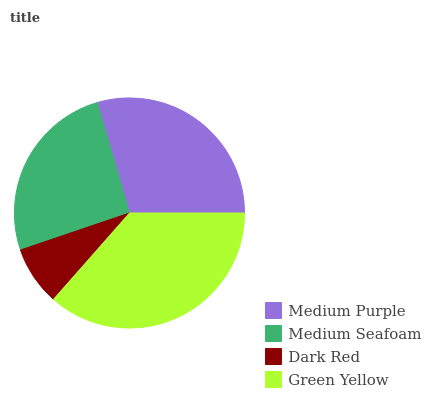Is Dark Red the minimum?
Answer yes or no. Yes. Is Green Yellow the maximum?
Answer yes or no. Yes. Is Medium Seafoam the minimum?
Answer yes or no. No. Is Medium Seafoam the maximum?
Answer yes or no. No. Is Medium Purple greater than Medium Seafoam?
Answer yes or no. Yes. Is Medium Seafoam less than Medium Purple?
Answer yes or no. Yes. Is Medium Seafoam greater than Medium Purple?
Answer yes or no. No. Is Medium Purple less than Medium Seafoam?
Answer yes or no. No. Is Medium Purple the high median?
Answer yes or no. Yes. Is Medium Seafoam the low median?
Answer yes or no. Yes. Is Green Yellow the high median?
Answer yes or no. No. Is Dark Red the low median?
Answer yes or no. No. 